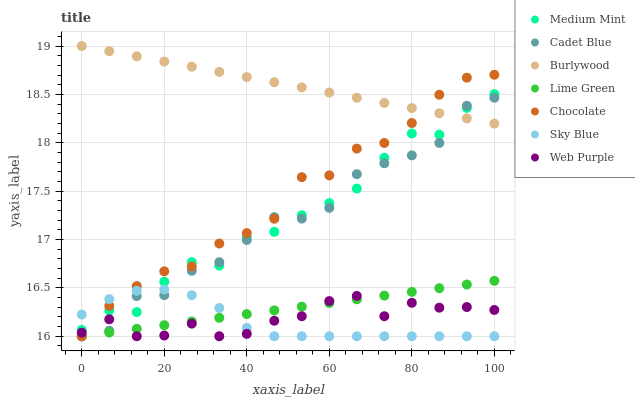Does Sky Blue have the minimum area under the curve?
Answer yes or no. Yes. Does Burlywood have the maximum area under the curve?
Answer yes or no. Yes. Does Cadet Blue have the minimum area under the curve?
Answer yes or no. No. Does Cadet Blue have the maximum area under the curve?
Answer yes or no. No. Is Lime Green the smoothest?
Answer yes or no. Yes. Is Cadet Blue the roughest?
Answer yes or no. Yes. Is Burlywood the smoothest?
Answer yes or no. No. Is Burlywood the roughest?
Answer yes or no. No. Does Cadet Blue have the lowest value?
Answer yes or no. Yes. Does Burlywood have the lowest value?
Answer yes or no. No. Does Burlywood have the highest value?
Answer yes or no. Yes. Does Cadet Blue have the highest value?
Answer yes or no. No. Is Lime Green less than Burlywood?
Answer yes or no. Yes. Is Medium Mint greater than Lime Green?
Answer yes or no. Yes. Does Lime Green intersect Cadet Blue?
Answer yes or no. Yes. Is Lime Green less than Cadet Blue?
Answer yes or no. No. Is Lime Green greater than Cadet Blue?
Answer yes or no. No. Does Lime Green intersect Burlywood?
Answer yes or no. No. 